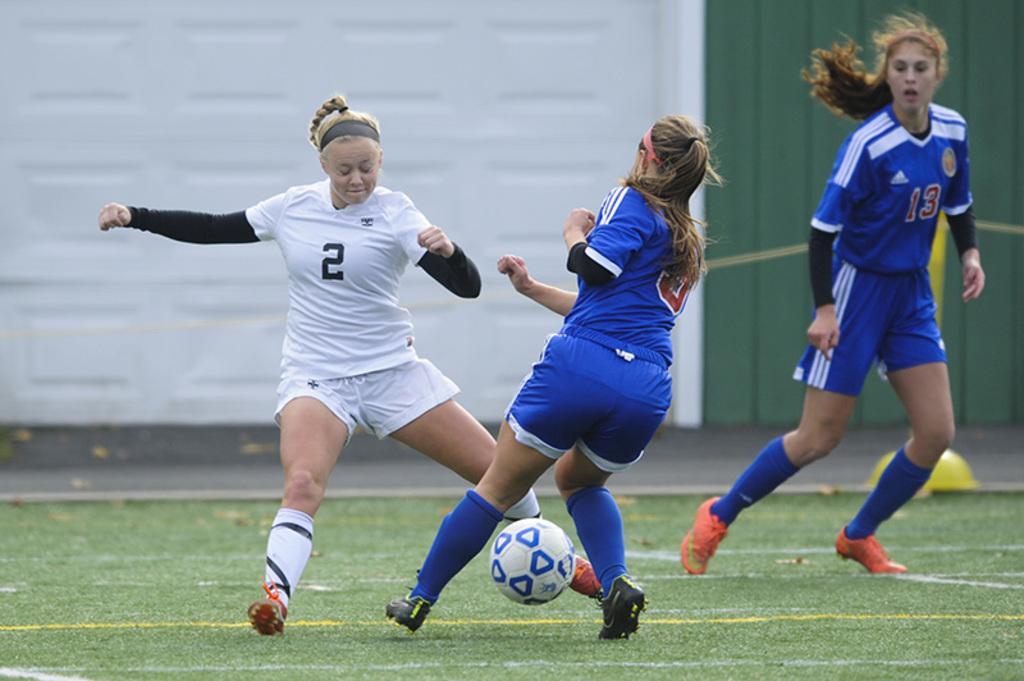Please provide a concise description of this image. Here we can see a woman are running on the ground, and playing with the ball, and at back here is the road. 